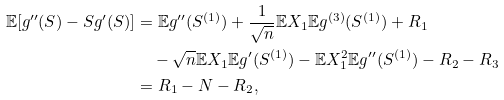<formula> <loc_0><loc_0><loc_500><loc_500>\mathbb { E } [ g ^ { \prime \prime } ( S ) - S g ^ { \prime } ( S ) ] & = \mathbb { E } g ^ { \prime \prime } ( S ^ { ( 1 ) } ) + \frac { 1 } { \sqrt { n } } \mathbb { E } X _ { 1 } \mathbb { E } g ^ { ( 3 ) } ( S ^ { ( 1 ) } ) + R _ { 1 } \\ & \quad - \sqrt { n } \mathbb { E } X _ { 1 } \mathbb { E } g ^ { \prime } ( S ^ { ( 1 ) } ) - \mathbb { E } X _ { 1 } ^ { 2 } \mathbb { E } g ^ { \prime \prime } ( S ^ { ( 1 ) } ) - R _ { 2 } - R _ { 3 } \\ & = R _ { 1 } - N - R _ { 2 } ,</formula> 